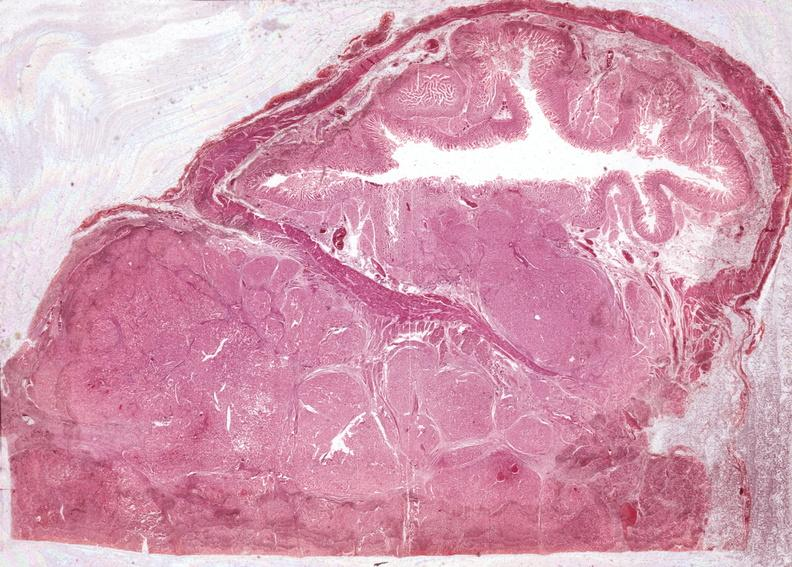s pancreas present?
Answer the question using a single word or phrase. Yes 